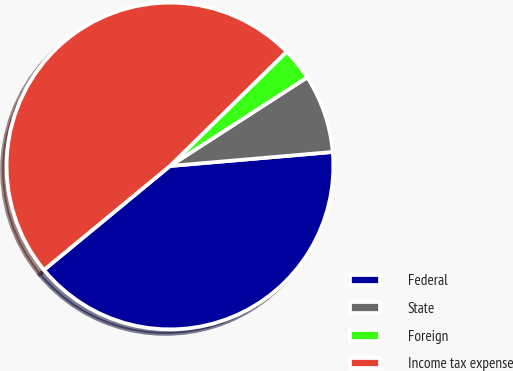<chart> <loc_0><loc_0><loc_500><loc_500><pie_chart><fcel>Federal<fcel>State<fcel>Foreign<fcel>Income tax expense<nl><fcel>40.39%<fcel>7.76%<fcel>3.21%<fcel>48.64%<nl></chart> 